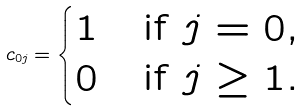<formula> <loc_0><loc_0><loc_500><loc_500>c _ { 0 j } = \begin{cases} 1 & \text {if $j=0$} , \\ 0 & \text {if $j\geq1$} . \end{cases}</formula> 